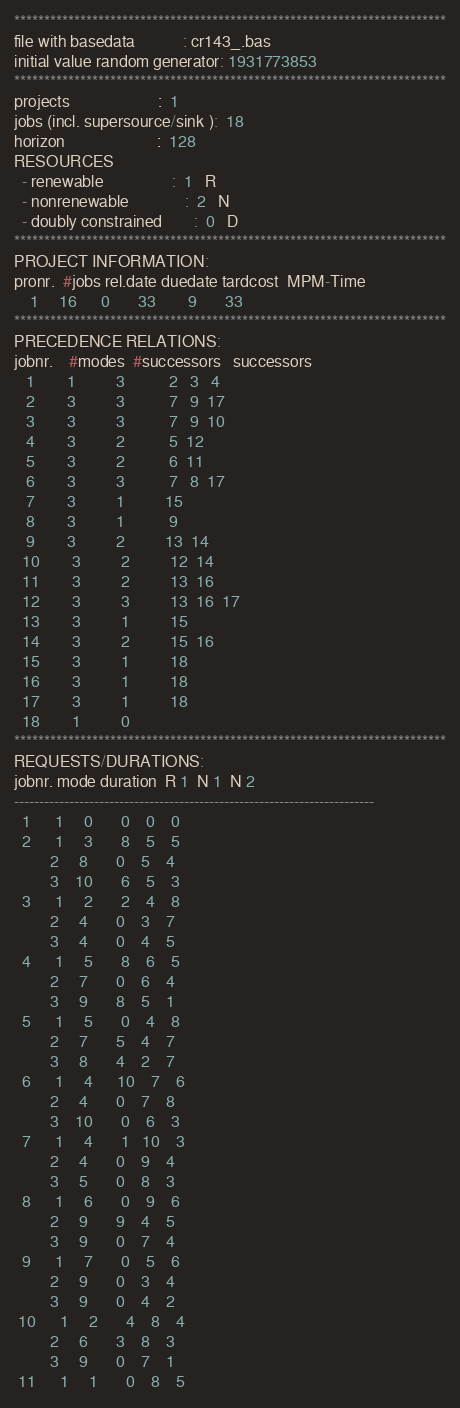<code> <loc_0><loc_0><loc_500><loc_500><_ObjectiveC_>************************************************************************
file with basedata            : cr143_.bas
initial value random generator: 1931773853
************************************************************************
projects                      :  1
jobs (incl. supersource/sink ):  18
horizon                       :  128
RESOURCES
  - renewable                 :  1   R
  - nonrenewable              :  2   N
  - doubly constrained        :  0   D
************************************************************************
PROJECT INFORMATION:
pronr.  #jobs rel.date duedate tardcost  MPM-Time
    1     16      0       33        9       33
************************************************************************
PRECEDENCE RELATIONS:
jobnr.    #modes  #successors   successors
   1        1          3           2   3   4
   2        3          3           7   9  17
   3        3          3           7   9  10
   4        3          2           5  12
   5        3          2           6  11
   6        3          3           7   8  17
   7        3          1          15
   8        3          1           9
   9        3          2          13  14
  10        3          2          12  14
  11        3          2          13  16
  12        3          3          13  16  17
  13        3          1          15
  14        3          2          15  16
  15        3          1          18
  16        3          1          18
  17        3          1          18
  18        1          0        
************************************************************************
REQUESTS/DURATIONS:
jobnr. mode duration  R 1  N 1  N 2
------------------------------------------------------------------------
  1      1     0       0    0    0
  2      1     3       8    5    5
         2     8       0    5    4
         3    10       6    5    3
  3      1     2       2    4    8
         2     4       0    3    7
         3     4       0    4    5
  4      1     5       8    6    5
         2     7       0    6    4
         3     9       8    5    1
  5      1     5       0    4    8
         2     7       5    4    7
         3     8       4    2    7
  6      1     4      10    7    6
         2     4       0    7    8
         3    10       0    6    3
  7      1     4       1   10    3
         2     4       0    9    4
         3     5       0    8    3
  8      1     6       0    9    6
         2     9       9    4    5
         3     9       0    7    4
  9      1     7       0    5    6
         2     9       0    3    4
         3     9       0    4    2
 10      1     2       4    8    4
         2     6       3    8    3
         3     9       0    7    1
 11      1     1       0    8    5</code> 